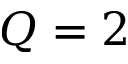<formula> <loc_0><loc_0><loc_500><loc_500>Q = 2</formula> 